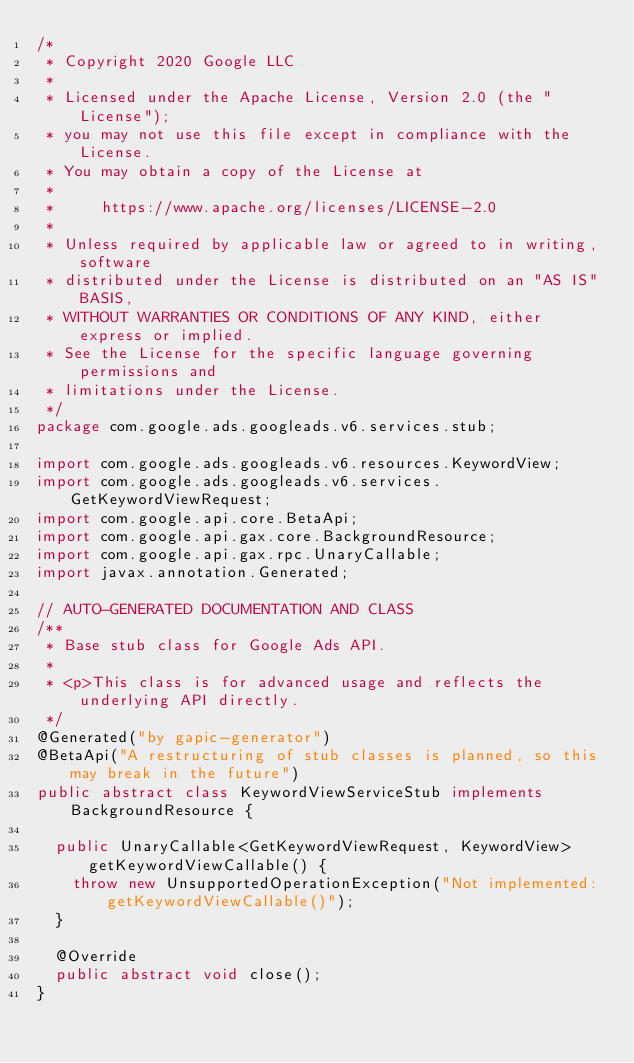Convert code to text. <code><loc_0><loc_0><loc_500><loc_500><_Java_>/*
 * Copyright 2020 Google LLC
 *
 * Licensed under the Apache License, Version 2.0 (the "License");
 * you may not use this file except in compliance with the License.
 * You may obtain a copy of the License at
 *
 *     https://www.apache.org/licenses/LICENSE-2.0
 *
 * Unless required by applicable law or agreed to in writing, software
 * distributed under the License is distributed on an "AS IS" BASIS,
 * WITHOUT WARRANTIES OR CONDITIONS OF ANY KIND, either express or implied.
 * See the License for the specific language governing permissions and
 * limitations under the License.
 */
package com.google.ads.googleads.v6.services.stub;

import com.google.ads.googleads.v6.resources.KeywordView;
import com.google.ads.googleads.v6.services.GetKeywordViewRequest;
import com.google.api.core.BetaApi;
import com.google.api.gax.core.BackgroundResource;
import com.google.api.gax.rpc.UnaryCallable;
import javax.annotation.Generated;

// AUTO-GENERATED DOCUMENTATION AND CLASS
/**
 * Base stub class for Google Ads API.
 *
 * <p>This class is for advanced usage and reflects the underlying API directly.
 */
@Generated("by gapic-generator")
@BetaApi("A restructuring of stub classes is planned, so this may break in the future")
public abstract class KeywordViewServiceStub implements BackgroundResource {

  public UnaryCallable<GetKeywordViewRequest, KeywordView> getKeywordViewCallable() {
    throw new UnsupportedOperationException("Not implemented: getKeywordViewCallable()");
  }

  @Override
  public abstract void close();
}
</code> 